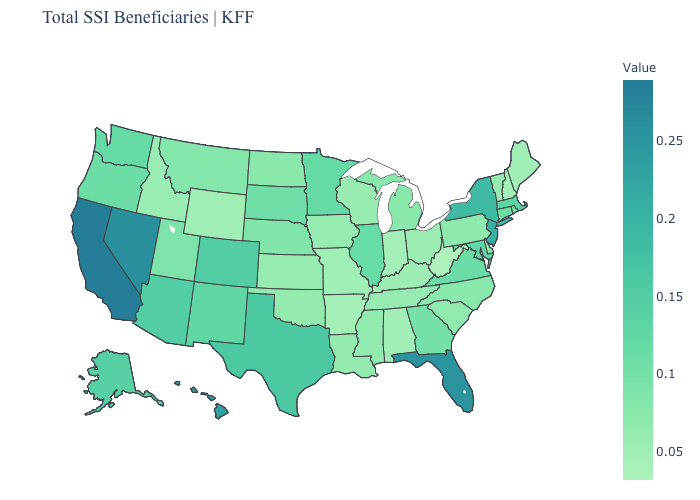Does Texas have the highest value in the USA?
Concise answer only. No. Among the states that border Delaware , which have the lowest value?
Write a very short answer. Pennsylvania. Does the map have missing data?
Concise answer only. No. Does the map have missing data?
Quick response, please. No. 